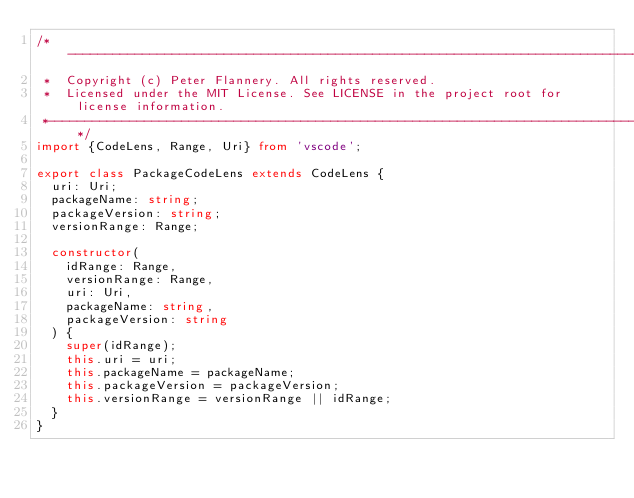<code> <loc_0><loc_0><loc_500><loc_500><_TypeScript_>/*---------------------------------------------------------------------------------------------
 *  Copyright (c) Peter Flannery. All rights reserved.
 *  Licensed under the MIT License. See LICENSE in the project root for license information.
 *--------------------------------------------------------------------------------------------*/
import {CodeLens, Range, Uri} from 'vscode';

export class PackageCodeLens extends CodeLens {
  uri: Uri;
  packageName: string;
  packageVersion: string;
  versionRange: Range;

  constructor(
    idRange: Range,
    versionRange: Range,
    uri: Uri,
    packageName: string,
    packageVersion: string
  ) {
    super(idRange);
    this.uri = uri;
    this.packageName = packageName;
    this.packageVersion = packageVersion;
    this.versionRange = versionRange || idRange;
  }
}</code> 